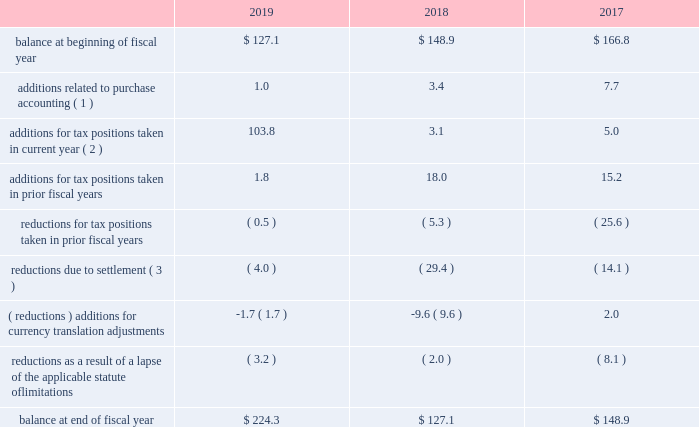Westrock company notes to consolidated financial statements 2014 ( continued ) consistent with prior years , we consider a portion of our earnings from certain foreign subsidiaries as subject to repatriation and we provide for taxes accordingly .
However , we consider the unremitted earnings and all other outside basis differences from all other foreign subsidiaries to be indefinitely reinvested .
Accordingly , we have not provided for any taxes that would be due .
As of september 30 , 2019 , we estimate our outside basis difference in foreign subsidiaries that are considered indefinitely reinvested to be approximately $ 1.6 billion .
The components of the outside basis difference are comprised of purchase accounting adjustments , undistributed earnings , and equity components .
Except for the portion of our earnings from certain foreign subsidiaries where we provided for taxes , we have not provided for any taxes that would be due upon the reversal of the outside basis differences .
However , in the event of a distribution in the form of dividends or dispositions of the subsidiaries , we may be subject to incremental u.s .
Income taxes , subject to an adjustment for foreign tax credits , and withholding taxes or income taxes payable to the foreign jurisdictions .
As of september 30 , 2019 , the determination of the amount of unrecognized deferred tax liability related to any remaining undistributed foreign earnings not subject to the transition tax and additional outside basis differences is not practicable .
A reconciliation of the beginning and ending amount of gross unrecognized tax benefits is as follows ( in millions ) : .
( 1 ) amounts in fiscal 2019 relate to the kapstone acquisition .
Amounts in fiscal 2018 and 2017 relate to the mps acquisition .
( 2 ) additions for tax positions taken in current fiscal year includes primarily positions taken related to foreign subsidiaries .
( 3 ) amounts in fiscal 2019 relate to the settlements of state and foreign audit examinations .
Amounts in fiscal 2018 relate to the settlement of state audit examinations and federal and state amended returns filed related to affirmative adjustments for which there was a reserve .
Amounts in fiscal 2017 relate to the settlement of federal and state audit examinations with taxing authorities .
As of september 30 , 2019 and 2018 , the total amount of unrecognized tax benefits was approximately $ 224.3 million and $ 127.1 million , respectively , exclusive of interest and penalties .
Of these balances , as of september 30 , 2019 and 2018 , if we were to prevail on all unrecognized tax benefits recorded , approximately $ 207.5 million and $ 108.7 million , respectively , would benefit the effective tax rate .
We regularly evaluate , assess and adjust the related liabilities in light of changing facts and circumstances , which could cause the effective tax rate to fluctuate from period to period .
Resolution of the uncertain tax positions could have a material adverse effect on our cash flows or materially benefit our results of operations in future periods depending upon their ultimate resolution .
See 201cnote 18 .
Commitments and contingencies 2014 brazil tax liability 201d we recognize estimated interest and penalties related to unrecognized tax benefits in income tax expense in the consolidated statements of income .
As of september 30 , 2019 , we had liabilities of $ 80.0 million related to estimated interest and penalties for unrecognized tax benefits .
As of september 30 , 2018 , we had liabilities of $ 70.4 million , related to estimated interest and penalties for unrecognized tax benefits .
Our results of operations for the fiscal year ended september 30 , 2019 , 2018 and 2017 include expense of $ 9.7 million , $ 5.8 million and $ 7.4 million , respectively , net of indirect benefits , related to estimated interest and penalties with respect to the liability for unrecognized tax benefits .
As of september 30 , 2019 , it is reasonably possible that our unrecognized tax benefits will decrease by up to $ 8.7 million in the next twelve months due to expiration of various statues of limitations and settlement of issues. .
What was the percentage change in the gross unrecognized tax benefits from 2017 to 2018 $ 127.1? 
Computations: ((127.1 - 148.9) / 148.9)
Answer: -0.14641. 